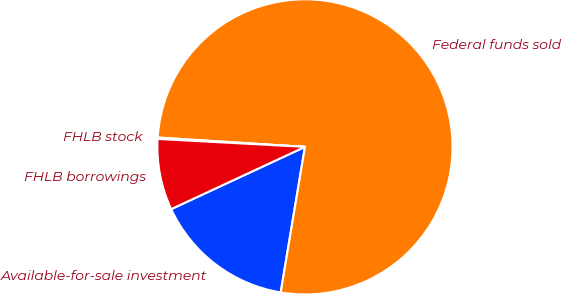<chart> <loc_0><loc_0><loc_500><loc_500><pie_chart><fcel>Available-for-sale investment<fcel>Federal funds sold<fcel>FHLB stock<fcel>FHLB borrowings<nl><fcel>15.44%<fcel>76.62%<fcel>0.15%<fcel>7.79%<nl></chart> 